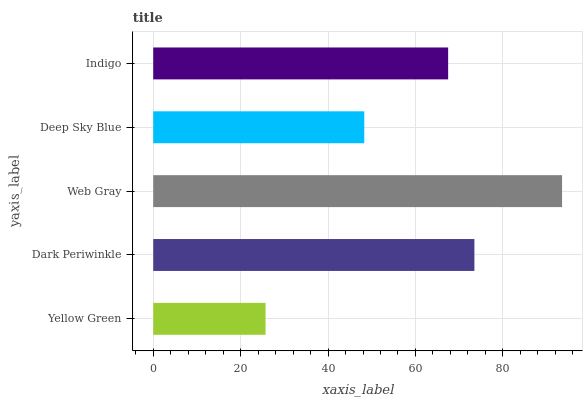Is Yellow Green the minimum?
Answer yes or no. Yes. Is Web Gray the maximum?
Answer yes or no. Yes. Is Dark Periwinkle the minimum?
Answer yes or no. No. Is Dark Periwinkle the maximum?
Answer yes or no. No. Is Dark Periwinkle greater than Yellow Green?
Answer yes or no. Yes. Is Yellow Green less than Dark Periwinkle?
Answer yes or no. Yes. Is Yellow Green greater than Dark Periwinkle?
Answer yes or no. No. Is Dark Periwinkle less than Yellow Green?
Answer yes or no. No. Is Indigo the high median?
Answer yes or no. Yes. Is Indigo the low median?
Answer yes or no. Yes. Is Deep Sky Blue the high median?
Answer yes or no. No. Is Yellow Green the low median?
Answer yes or no. No. 